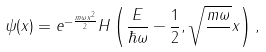Convert formula to latex. <formula><loc_0><loc_0><loc_500><loc_500>\psi ( x ) = e ^ { - \frac { m \omega x ^ { 2 } } { 2 } } H \left ( \frac { E } { \hbar { \omega } } - \frac { 1 } { 2 } , \sqrt { \frac { m \omega } { } } x \right ) ,</formula> 